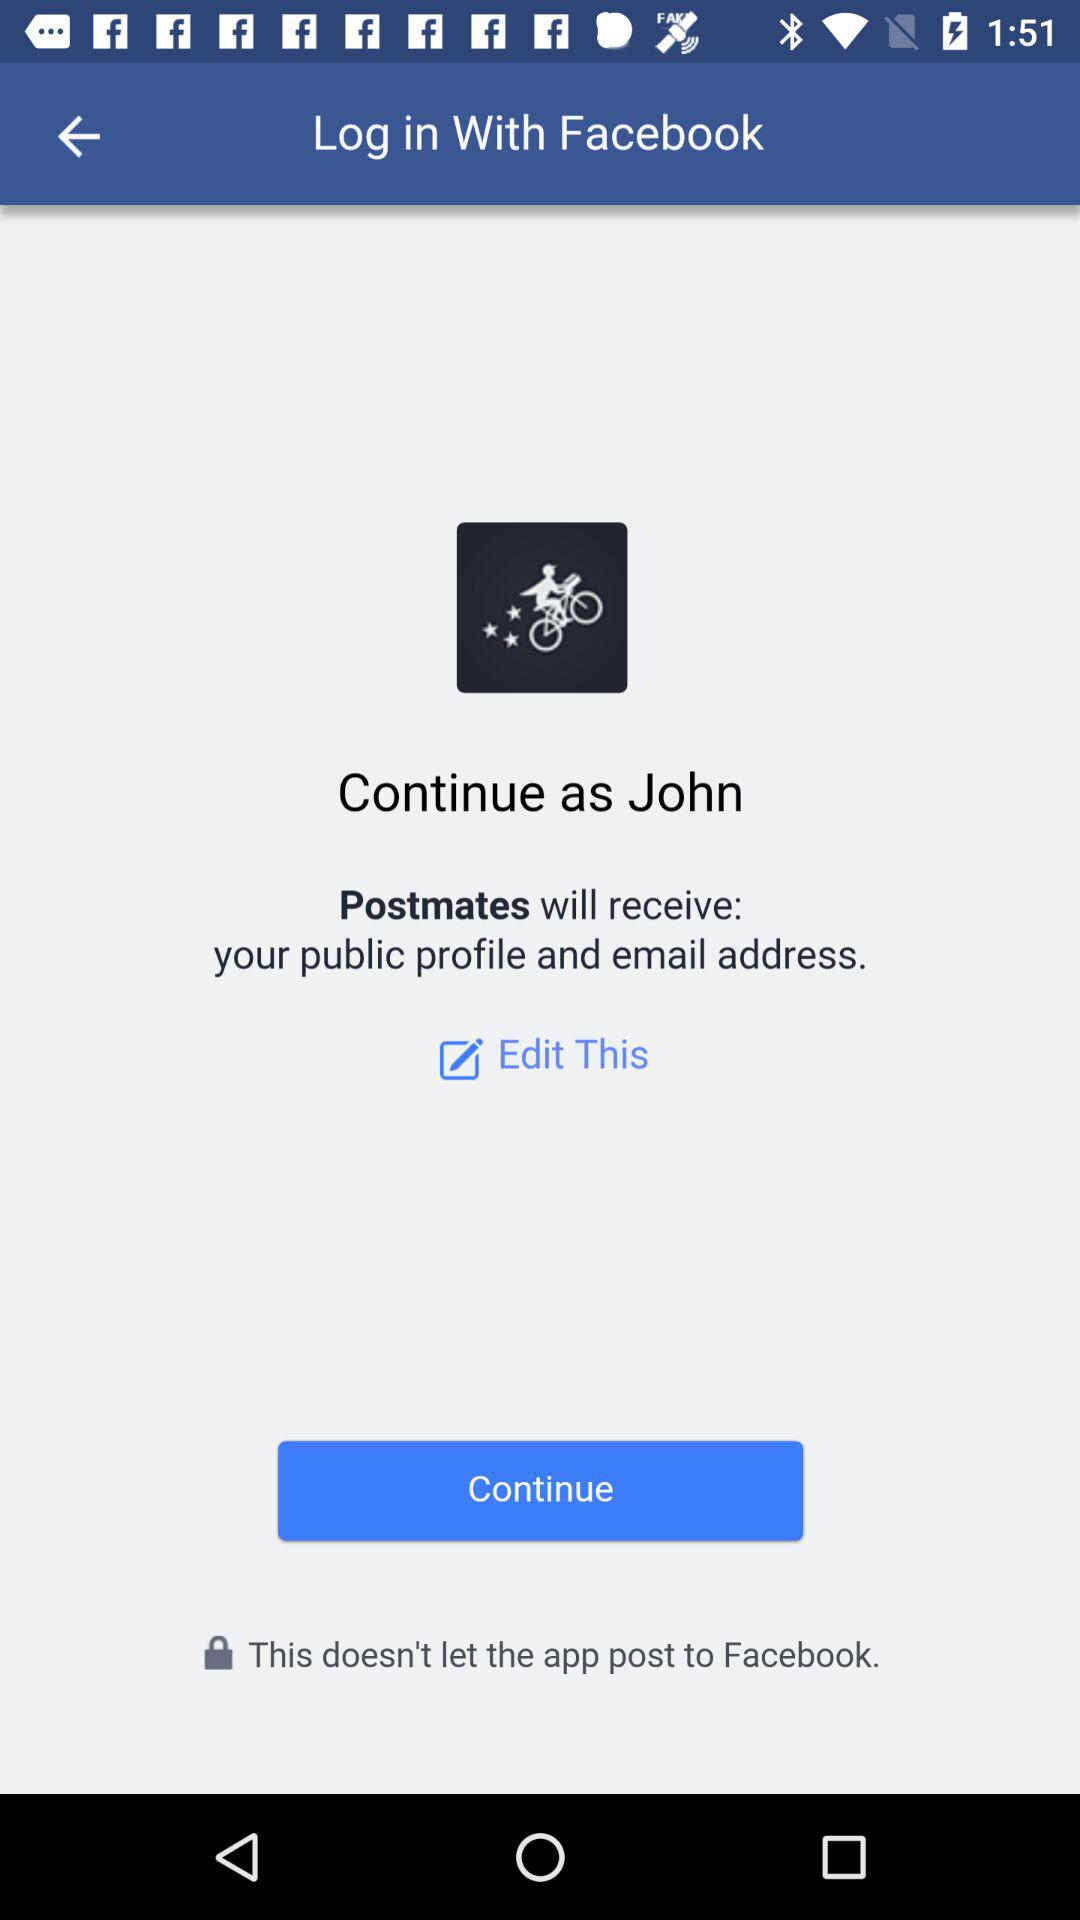What is the user name to continue the profile? The user name to continue the profile is John. 